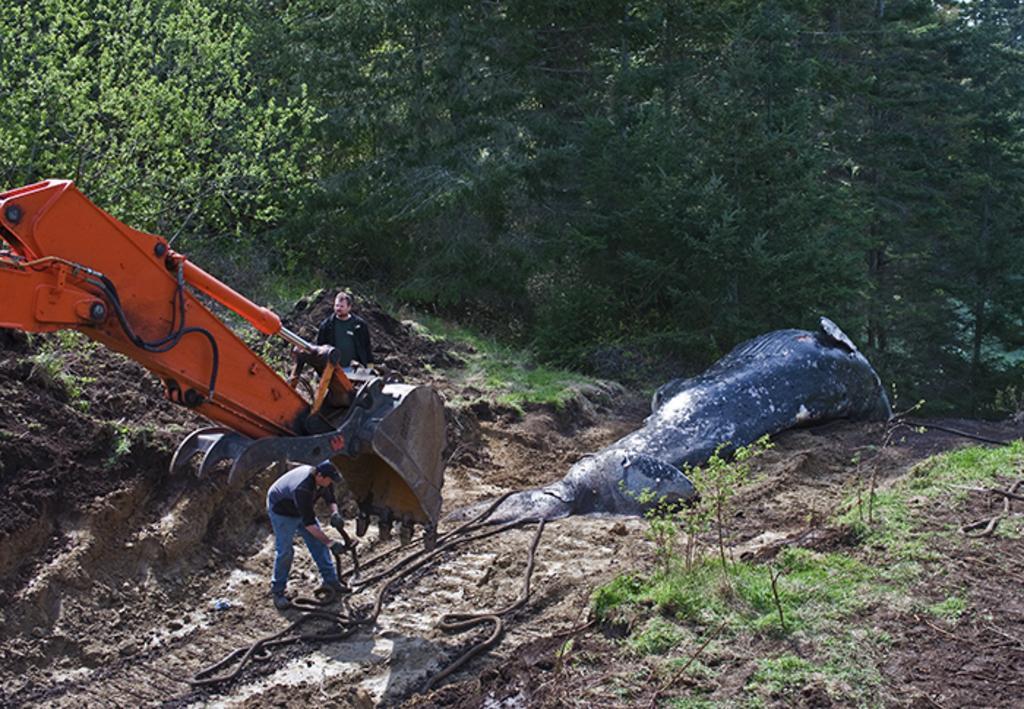How would you summarize this image in a sentence or two? In this picture we can see two men and an earth moving vehicle, in front of them we can find a fish on the ground, and also we can see trees. 